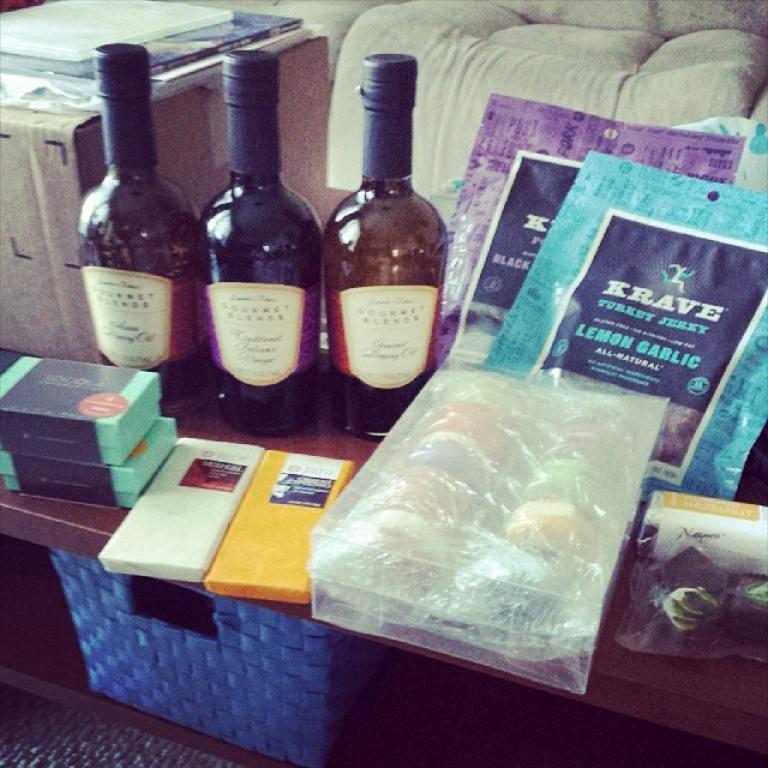Provide a one-sentence caption for the provided image. Three wine bottles are next to two packages of  Krave jerky. 